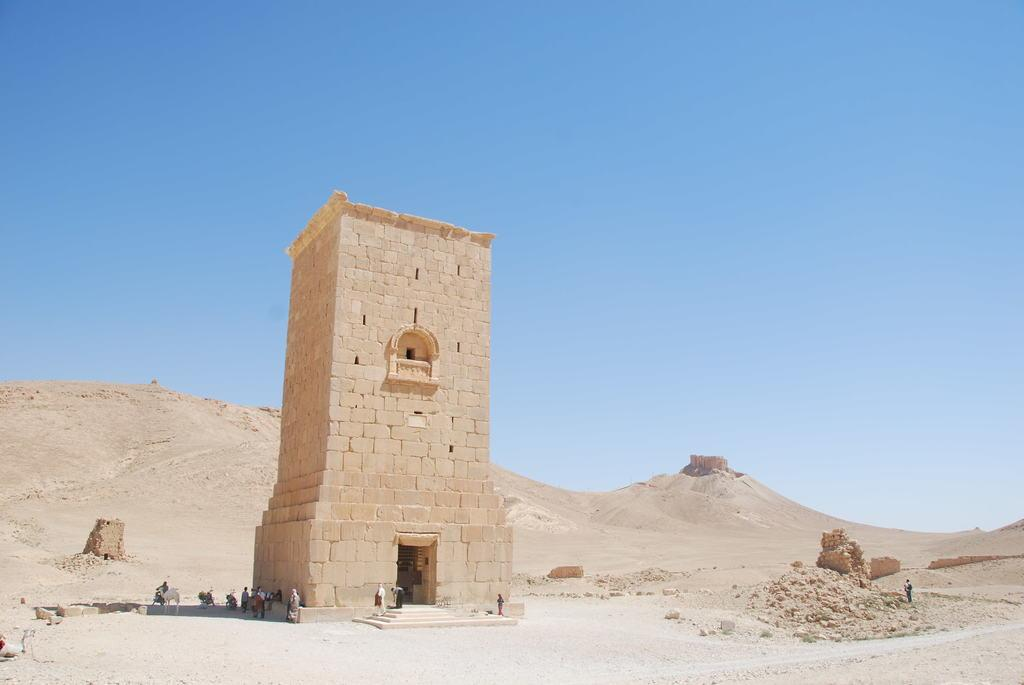What is the main subject in the middle of the image? There is an architecture in the middle of the image. What can be seen in the background of the image? There are hills and the sky visible in the background of the image. How many people are present in the middle of the image? There are many people in the middle of the image. What other objects or living beings can be seen in the middle of the image? There are vehicles, animals, stones, and land in the middle of the image. What type of clam is being used as a decoration on the architecture in the image? There is no clam present in the image, and therefore no such decoration. 